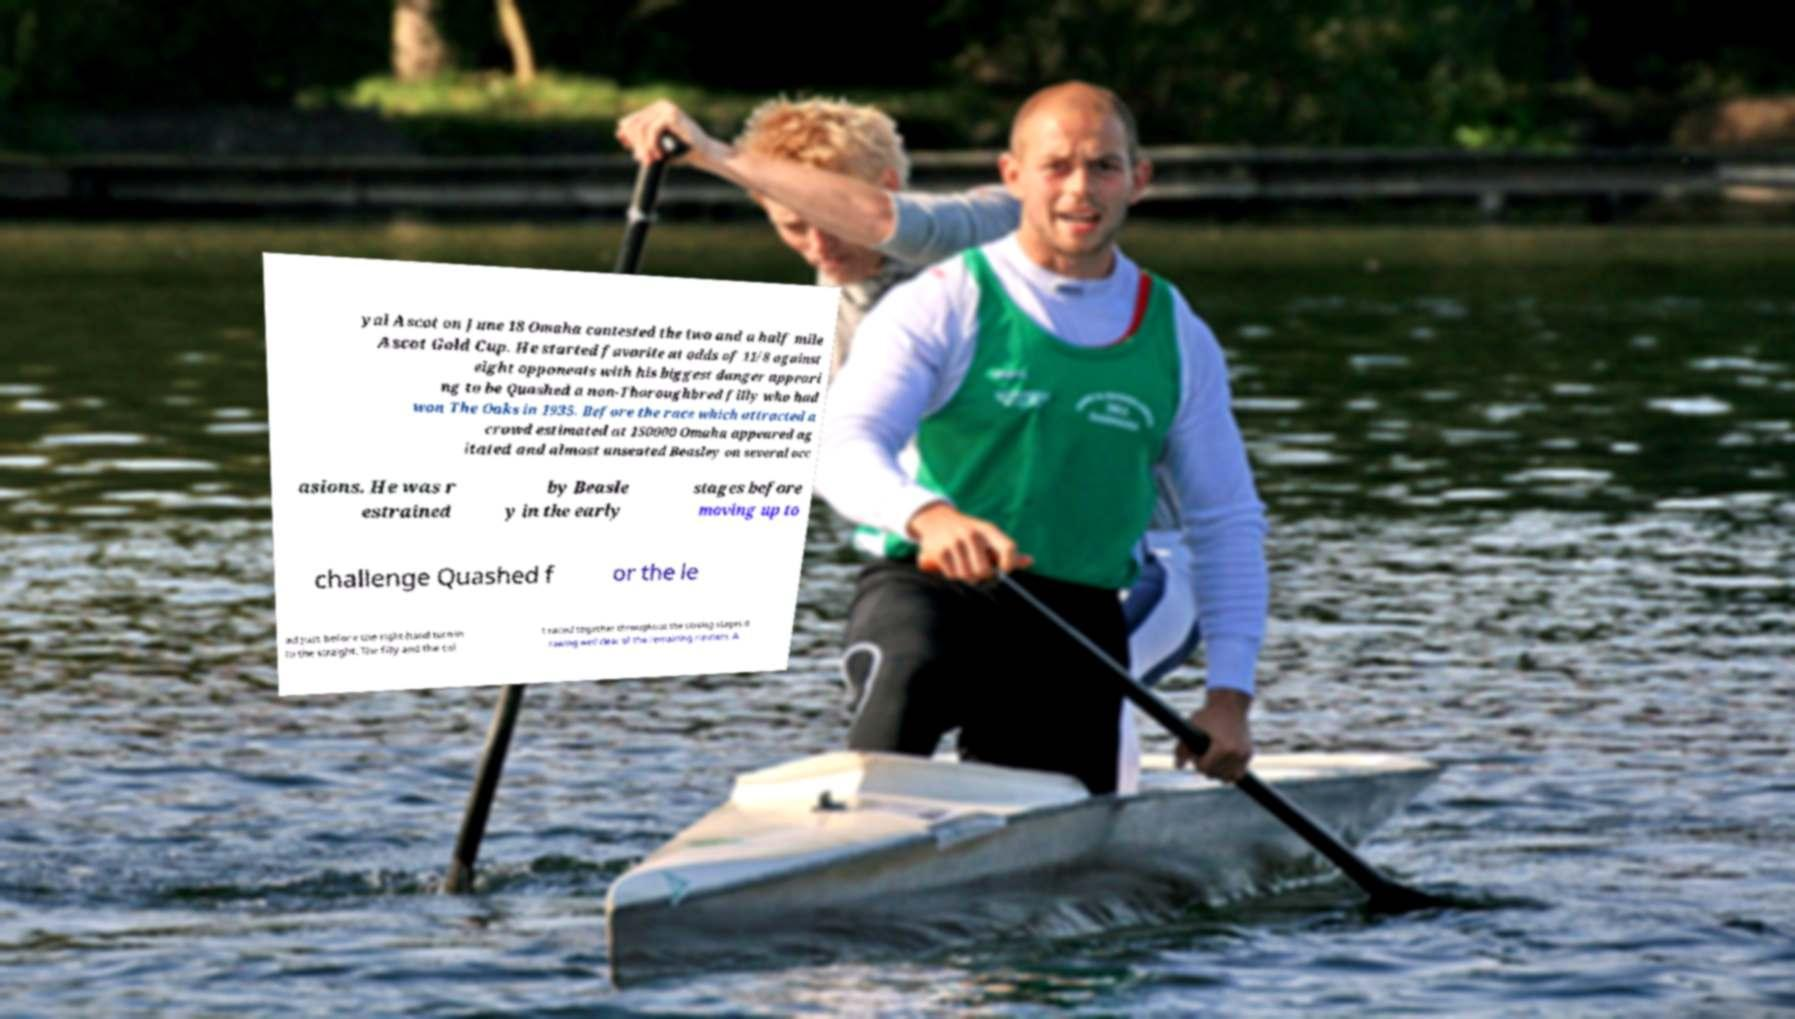Please identify and transcribe the text found in this image. yal Ascot on June 18 Omaha contested the two and a half mile Ascot Gold Cup. He started favorite at odds of 11/8 against eight opponents with his biggest danger appeari ng to be Quashed a non-Thoroughbred filly who had won The Oaks in 1935. Before the race which attracted a crowd estimated at 150000 Omaha appeared ag itated and almost unseated Beasley on several occ asions. He was r estrained by Beasle y in the early stages before moving up to challenge Quashed f or the le ad just before the right-hand turn in to the straight. The filly and the col t raced together throughout the closing stages d rawing well clear of the remaining runners. A 